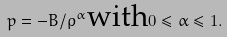<formula> <loc_0><loc_0><loc_500><loc_500>p = - B / \rho ^ { \alpha } \text {with} 0 \leq \alpha \leq 1 .</formula> 